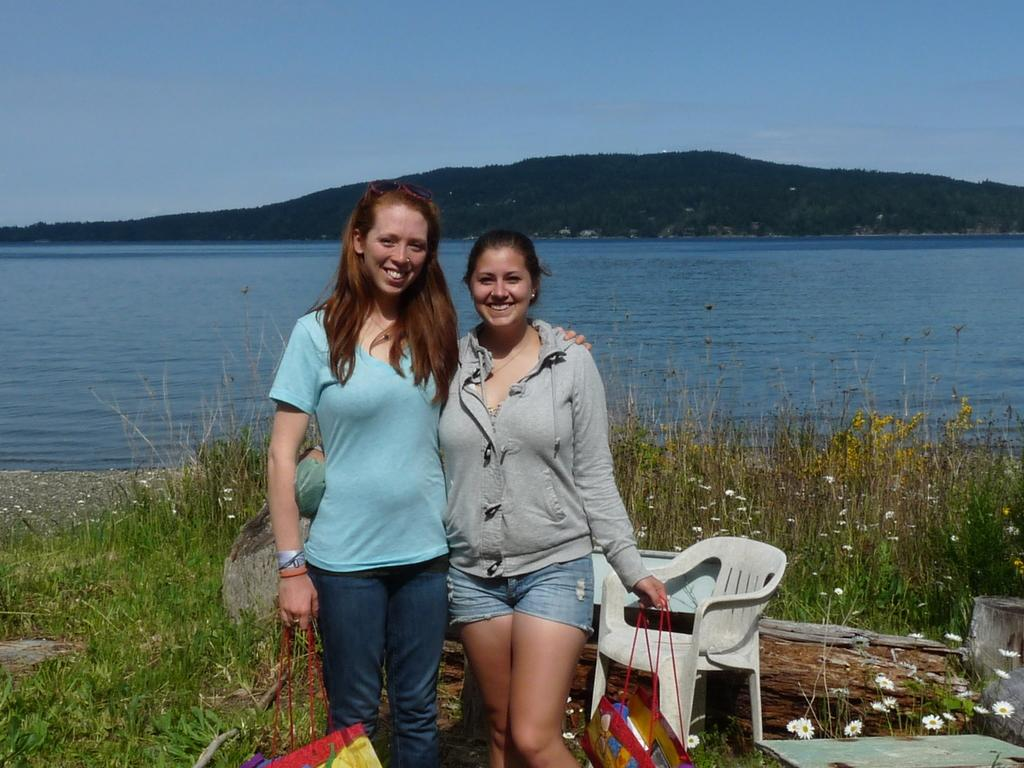Who is present in the image? There are women in the image. What are the women doing in the image? The women are standing and holding bags. What can be seen in the background of the image? There is a river visible in the background of the image. What type of fan can be seen in the image? There is no fan present in the image. 